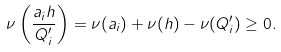<formula> <loc_0><loc_0><loc_500><loc_500>\nu \left ( \frac { a _ { i } h } { Q ^ { \prime } _ { i } } \right ) = \nu ( a _ { i } ) + \nu ( h ) - \nu ( Q _ { i } ^ { \prime } ) \geq 0 .</formula> 